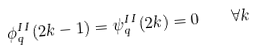<formula> <loc_0><loc_0><loc_500><loc_500>\phi _ { q } ^ { I I } ( 2 k - 1 ) = \psi _ { q } ^ { I I } ( 2 k ) = 0 \, \quad \forall k</formula> 